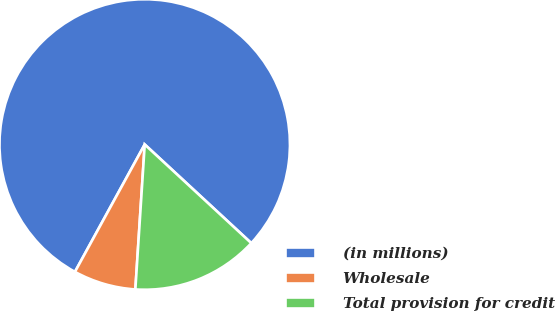Convert chart to OTSL. <chart><loc_0><loc_0><loc_500><loc_500><pie_chart><fcel>(in millions)<fcel>Wholesale<fcel>Total provision for credit<nl><fcel>78.91%<fcel>6.95%<fcel>14.14%<nl></chart> 